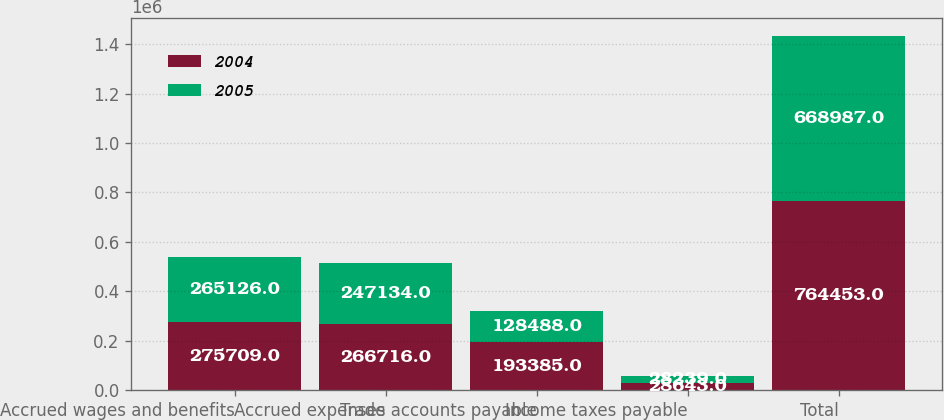Convert chart to OTSL. <chart><loc_0><loc_0><loc_500><loc_500><stacked_bar_chart><ecel><fcel>Accrued wages and benefits<fcel>Accrued expenses<fcel>Trade accounts payable<fcel>Income taxes payable<fcel>Total<nl><fcel>2004<fcel>275709<fcel>266716<fcel>193385<fcel>28643<fcel>764453<nl><fcel>2005<fcel>265126<fcel>247134<fcel>128488<fcel>28239<fcel>668987<nl></chart> 